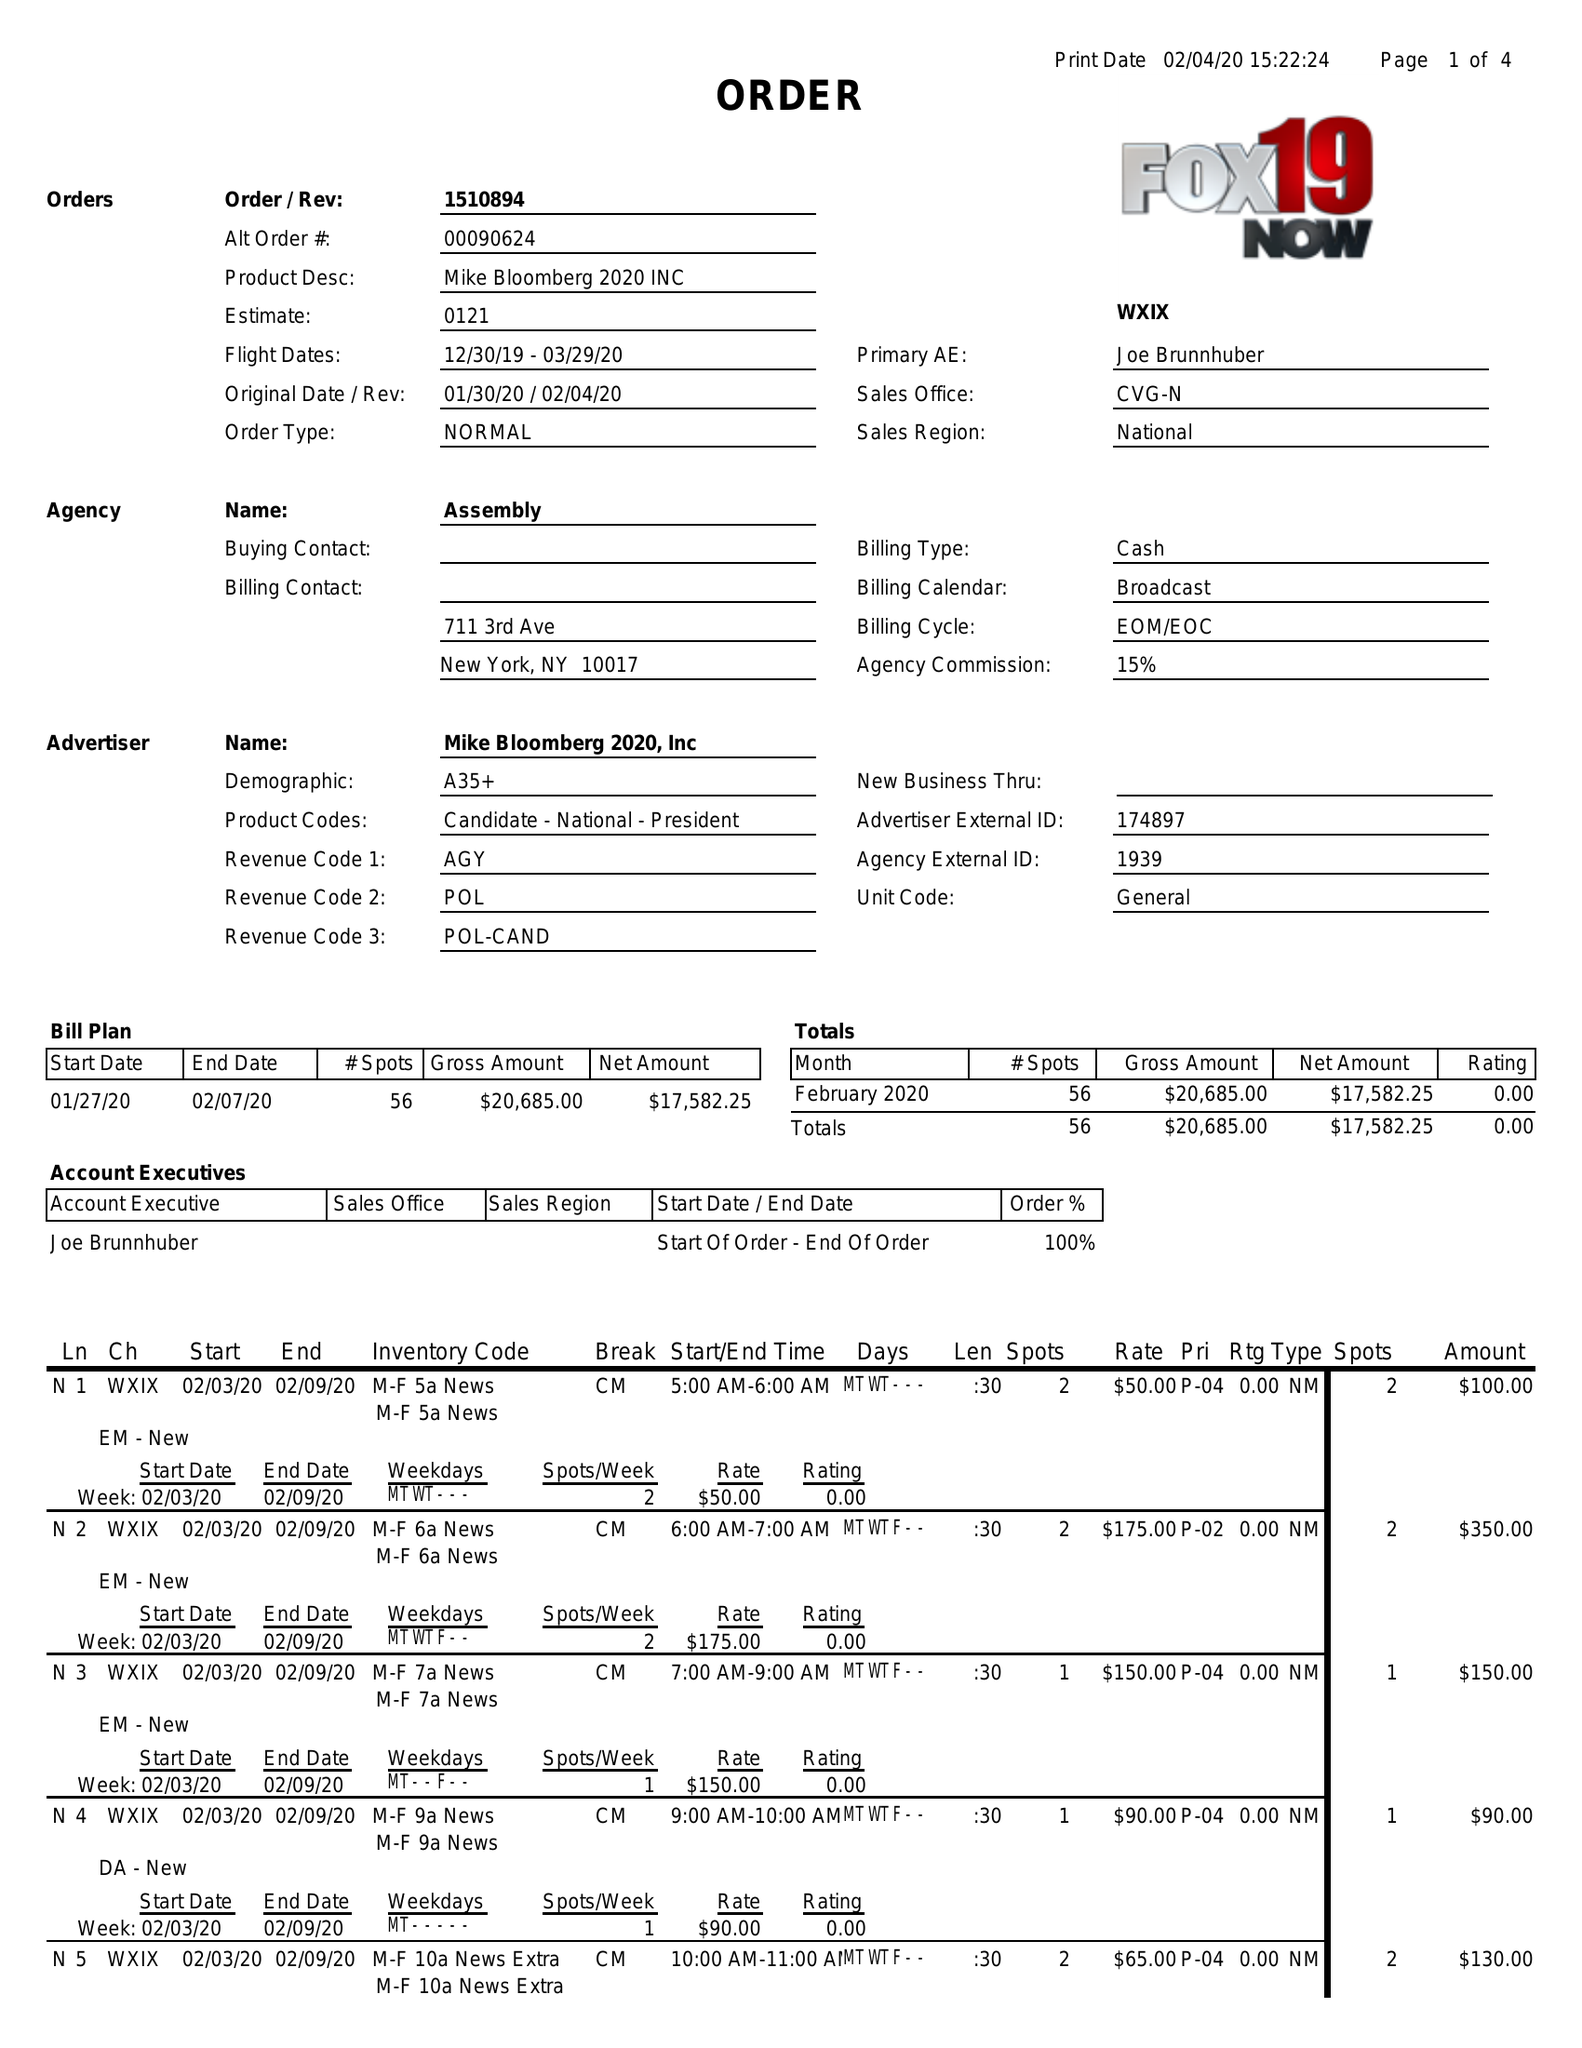What is the value for the contract_num?
Answer the question using a single word or phrase. 1510894 